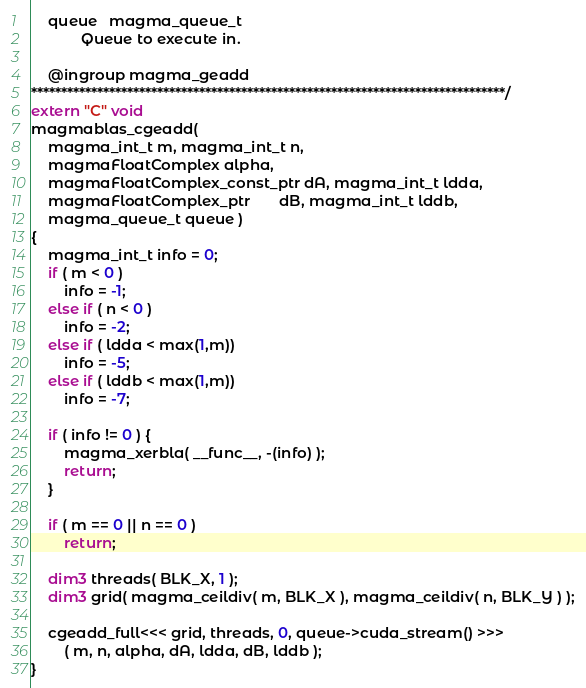<code> <loc_0><loc_0><loc_500><loc_500><_Cuda_>    queue   magma_queue_t
            Queue to execute in.

    @ingroup magma_geadd
*******************************************************************************/
extern "C" void
magmablas_cgeadd(
    magma_int_t m, magma_int_t n,
    magmaFloatComplex alpha,
    magmaFloatComplex_const_ptr dA, magma_int_t ldda,
    magmaFloatComplex_ptr       dB, magma_int_t lddb,
    magma_queue_t queue )
{
    magma_int_t info = 0;
    if ( m < 0 )
        info = -1;
    else if ( n < 0 )
        info = -2;
    else if ( ldda < max(1,m))
        info = -5;
    else if ( lddb < max(1,m))
        info = -7;
    
    if ( info != 0 ) {
        magma_xerbla( __func__, -(info) );
        return;
    }
    
    if ( m == 0 || n == 0 )
        return;
    
    dim3 threads( BLK_X, 1 );
    dim3 grid( magma_ceildiv( m, BLK_X ), magma_ceildiv( n, BLK_Y ) );
    
    cgeadd_full<<< grid, threads, 0, queue->cuda_stream() >>>
        ( m, n, alpha, dA, ldda, dB, lddb );
}
</code> 